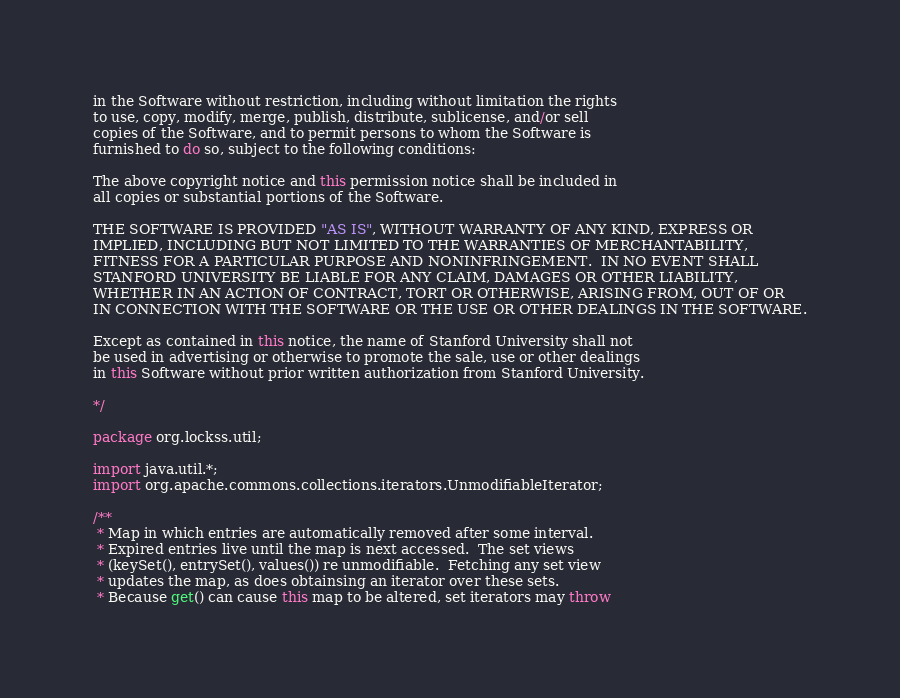Convert code to text. <code><loc_0><loc_0><loc_500><loc_500><_Java_>in the Software without restriction, including without limitation the rights
to use, copy, modify, merge, publish, distribute, sublicense, and/or sell
copies of the Software, and to permit persons to whom the Software is
furnished to do so, subject to the following conditions:

The above copyright notice and this permission notice shall be included in
all copies or substantial portions of the Software.

THE SOFTWARE IS PROVIDED "AS IS", WITHOUT WARRANTY OF ANY KIND, EXPRESS OR
IMPLIED, INCLUDING BUT NOT LIMITED TO THE WARRANTIES OF MERCHANTABILITY,
FITNESS FOR A PARTICULAR PURPOSE AND NONINFRINGEMENT.  IN NO EVENT SHALL
STANFORD UNIVERSITY BE LIABLE FOR ANY CLAIM, DAMAGES OR OTHER LIABILITY,
WHETHER IN AN ACTION OF CONTRACT, TORT OR OTHERWISE, ARISING FROM, OUT OF OR
IN CONNECTION WITH THE SOFTWARE OR THE USE OR OTHER DEALINGS IN THE SOFTWARE.

Except as contained in this notice, the name of Stanford University shall not
be used in advertising or otherwise to promote the sale, use or other dealings
in this Software without prior written authorization from Stanford University.

*/

package org.lockss.util;

import java.util.*;
import org.apache.commons.collections.iterators.UnmodifiableIterator;

/**
 * Map in which entries are automatically removed after some interval.
 * Expired entries live until the map is next accessed.  The set views
 * (keySet(), entrySet(), values()) re unmodifiable.  Fetching any set view
 * updates the map, as does obtainsing an iterator over these sets.
 * Because get() can cause this map to be altered, set iterators may throw</code> 